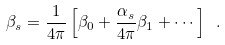<formula> <loc_0><loc_0><loc_500><loc_500>\beta _ { s } = \frac { 1 } { 4 \pi } \left [ \beta _ { 0 } + \frac { \alpha _ { s } } { 4 \pi } \beta _ { 1 } + \cdots \right ] \ .</formula> 